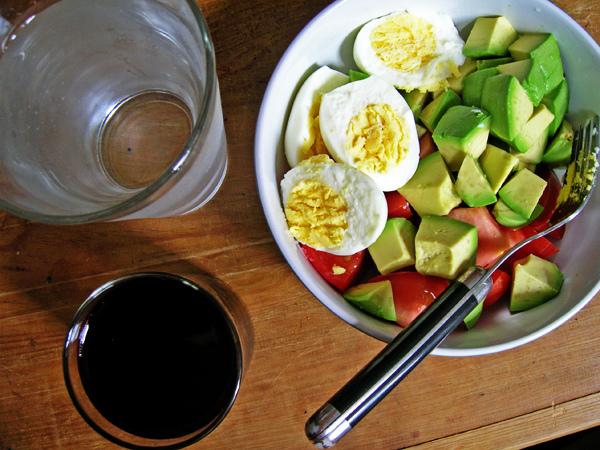Is this a lunch box?
Keep it brief. No. Is the cup full?
Give a very brief answer. Yes. What type of food is in the bowl?
Concise answer only. Salad. Could this be Japanese food?
Give a very brief answer. No. What color is the handle of the fork?
Concise answer only. Black. Is this lunch or dinner?
Answer briefly. Lunch. How many carrots is there?
Give a very brief answer. 0. What type of cuisine is this?
Answer briefly. American. What is the fork for?
Quick response, please. Eating. Is this Western or Asian food?
Short answer required. Western. What color is the bowl?
Give a very brief answer. White. What is on the cutting board?
Short answer required. Food. Is there a knife in the picture?
Answer briefly. No. How many egg halves?
Answer briefly. 4. What is red on the plate?
Give a very brief answer. Tomato. Are there more than one types of sauce?
Keep it brief. No. What fruit is in the bowl?
Short answer required. Avocado. How were the eggs cooked?
Quick response, please. Hard boiled. What course of a meal is this?
Write a very short answer. Salad. What is the utensil on the right?
Be succinct. Fork. 